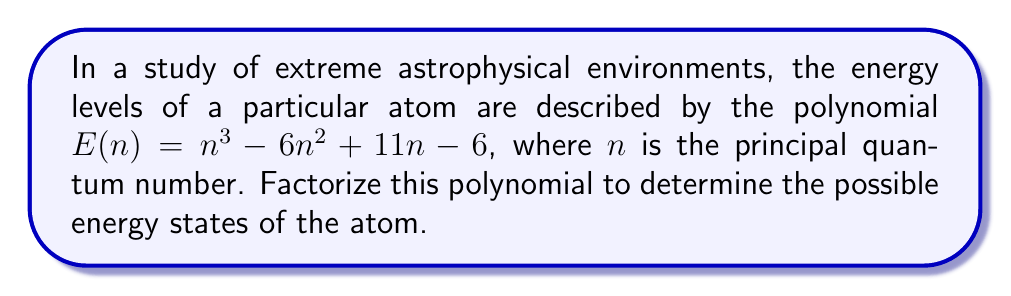Could you help me with this problem? To factorize the polynomial $E(n) = n^3 - 6n^2 + 11n - 6$, we'll follow these steps:

1) First, let's check if there are any rational roots using the rational root theorem. The possible rational roots are the factors of the constant term: ±1, ±2, ±3, ±6.

2) Testing these values, we find that $n = 1$ is a root of the polynomial.

3) We can factor out $(n - 1)$:
   $E(n) = (n - 1)(n^2 - 5n + 6)$

4) Now we need to factorize the quadratic term $n^2 - 5n + 6$. We can do this by finding two numbers that multiply to give 6 and add to give -5.

5) These numbers are -2 and -3.

6) So, we can rewrite the quadratic as:
   $n^2 - 5n + 6 = (n - 2)(n - 3)$

7) Putting it all together, we get:
   $E(n) = (n - 1)(n - 2)(n - 3)$

This factorization reveals that the possible energy states correspond to the principal quantum numbers $n = 1$, $n = 2$, and $n = 3$.
Answer: $E(n) = (n - 1)(n - 2)(n - 3)$ 